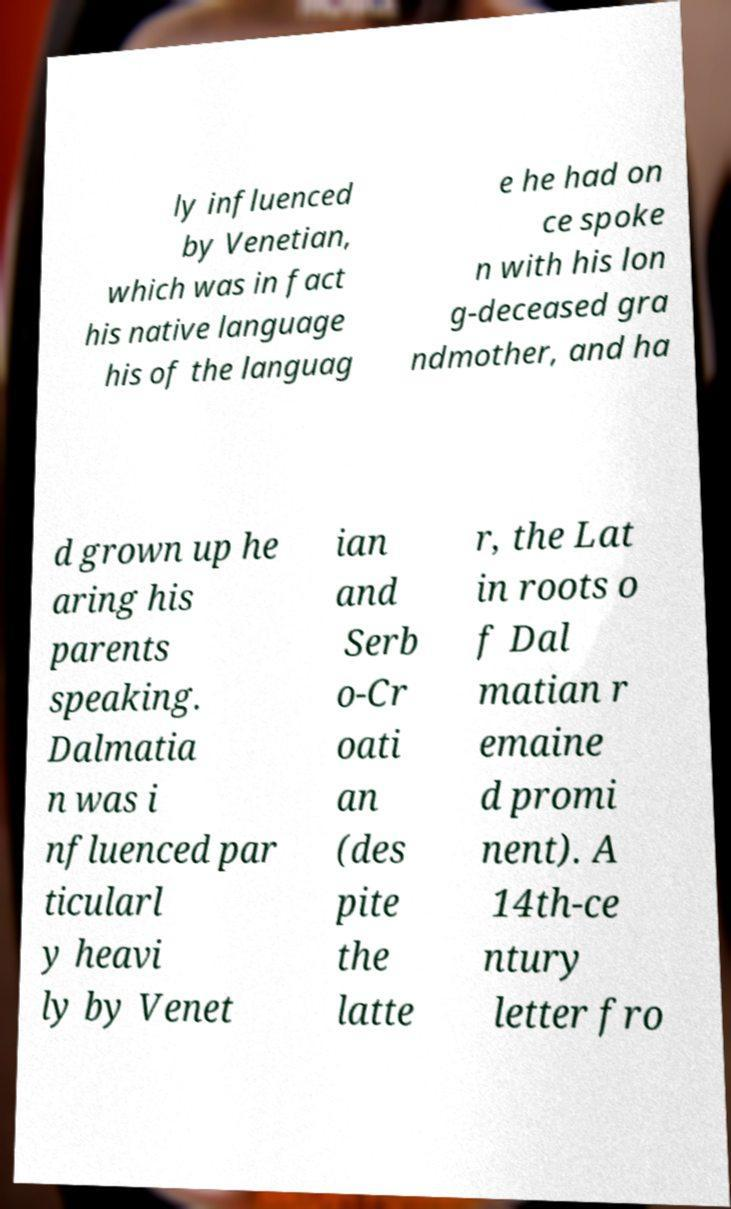Please identify and transcribe the text found in this image. ly influenced by Venetian, which was in fact his native language his of the languag e he had on ce spoke n with his lon g-deceased gra ndmother, and ha d grown up he aring his parents speaking. Dalmatia n was i nfluenced par ticularl y heavi ly by Venet ian and Serb o-Cr oati an (des pite the latte r, the Lat in roots o f Dal matian r emaine d promi nent). A 14th-ce ntury letter fro 